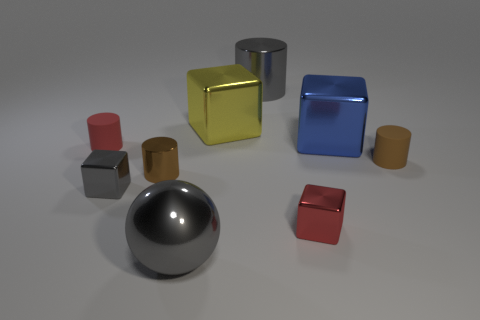There is a tiny gray metallic thing that is right of the red cylinder; is it the same shape as the big blue shiny object?
Provide a succinct answer. Yes. The ball that is the same material as the red cube is what color?
Your response must be concise. Gray. What material is the tiny cube that is left of the gray cylinder?
Ensure brevity in your answer.  Metal. There is a large yellow object; is its shape the same as the matte thing to the right of the big gray shiny ball?
Your answer should be compact. No. The thing that is both behind the tiny gray metal block and left of the small metal cylinder is made of what material?
Make the answer very short. Rubber. The other matte cylinder that is the same size as the red rubber cylinder is what color?
Provide a succinct answer. Brown. Are the gray cube and the tiny brown cylinder left of the big shiny cylinder made of the same material?
Your answer should be very brief. Yes. How many other things are the same size as the brown matte cylinder?
Your answer should be compact. 4. There is a small brown thing to the left of the big metallic block that is behind the blue cube; is there a tiny cylinder that is to the right of it?
Give a very brief answer. Yes. The red matte cylinder has what size?
Offer a very short reply. Small. 